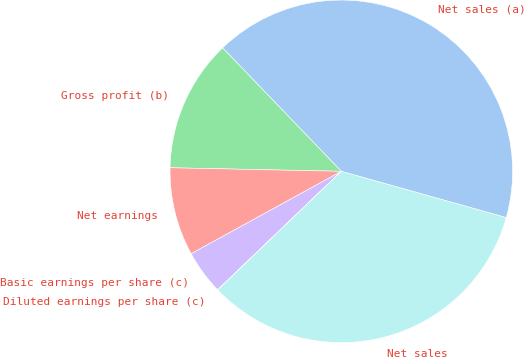Convert chart. <chart><loc_0><loc_0><loc_500><loc_500><pie_chart><fcel>Net sales (a)<fcel>Gross profit (b)<fcel>Net earnings<fcel>Basic earnings per share (c)<fcel>Diluted earnings per share (c)<fcel>Net sales<nl><fcel>41.54%<fcel>12.48%<fcel>8.32%<fcel>4.17%<fcel>0.02%<fcel>33.47%<nl></chart> 